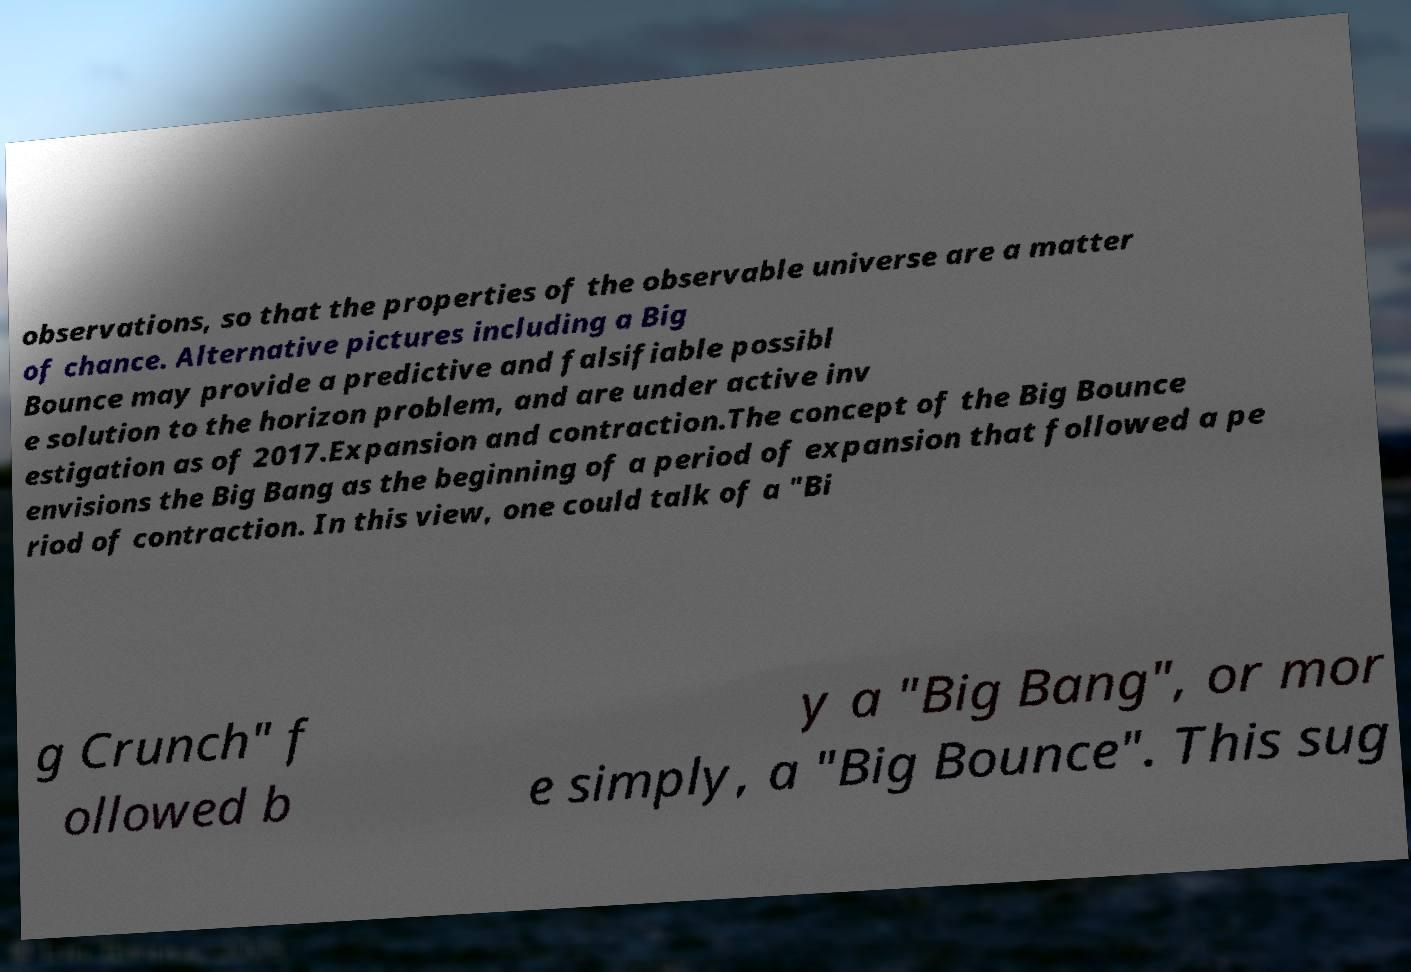Please read and relay the text visible in this image. What does it say? observations, so that the properties of the observable universe are a matter of chance. Alternative pictures including a Big Bounce may provide a predictive and falsifiable possibl e solution to the horizon problem, and are under active inv estigation as of 2017.Expansion and contraction.The concept of the Big Bounce envisions the Big Bang as the beginning of a period of expansion that followed a pe riod of contraction. In this view, one could talk of a "Bi g Crunch" f ollowed b y a "Big Bang", or mor e simply, a "Big Bounce". This sug 